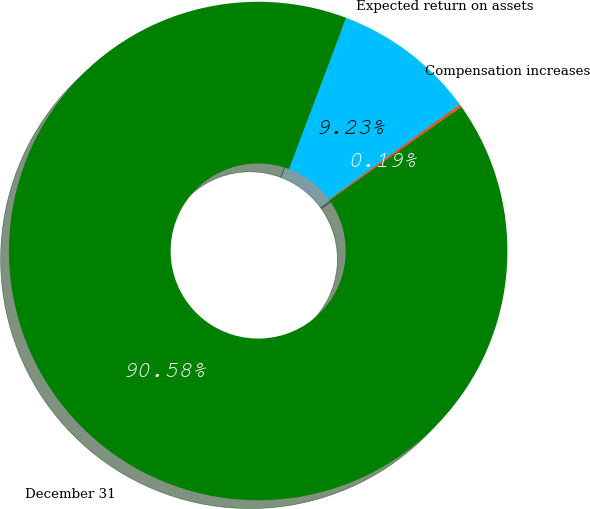<chart> <loc_0><loc_0><loc_500><loc_500><pie_chart><fcel>December 31<fcel>Compensation increases<fcel>Expected return on assets<nl><fcel>90.58%<fcel>0.19%<fcel>9.23%<nl></chart> 